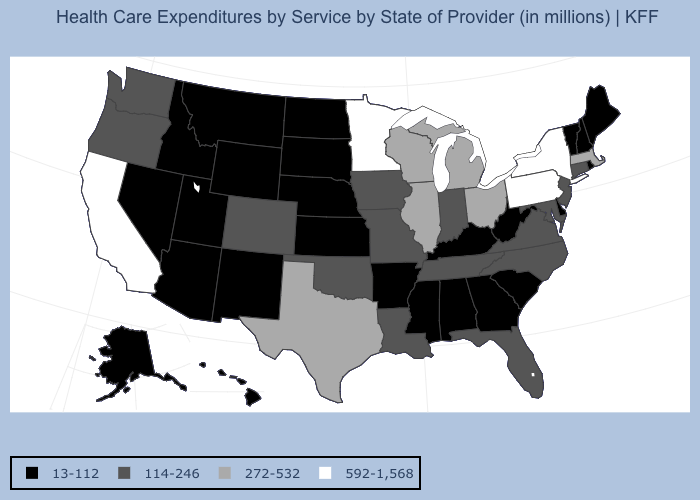Name the states that have a value in the range 13-112?
Keep it brief. Alabama, Alaska, Arizona, Arkansas, Delaware, Georgia, Hawaii, Idaho, Kansas, Kentucky, Maine, Mississippi, Montana, Nebraska, Nevada, New Hampshire, New Mexico, North Dakota, Rhode Island, South Carolina, South Dakota, Utah, Vermont, West Virginia, Wyoming. Which states have the highest value in the USA?
Write a very short answer. California, Minnesota, New York, Pennsylvania. What is the value of North Carolina?
Answer briefly. 114-246. Name the states that have a value in the range 114-246?
Keep it brief. Colorado, Connecticut, Florida, Indiana, Iowa, Louisiana, Maryland, Missouri, New Jersey, North Carolina, Oklahoma, Oregon, Tennessee, Virginia, Washington. What is the lowest value in states that border Alabama?
Quick response, please. 13-112. Among the states that border Oregon , which have the highest value?
Give a very brief answer. California. What is the value of Kentucky?
Be succinct. 13-112. What is the value of Maine?
Short answer required. 13-112. What is the highest value in the West ?
Quick response, please. 592-1,568. What is the value of Indiana?
Give a very brief answer. 114-246. Does California have the lowest value in the West?
Answer briefly. No. How many symbols are there in the legend?
Answer briefly. 4. What is the value of North Dakota?
Concise answer only. 13-112. Name the states that have a value in the range 272-532?
Quick response, please. Illinois, Massachusetts, Michigan, Ohio, Texas, Wisconsin. Does Kentucky have a lower value than Maine?
Answer briefly. No. 